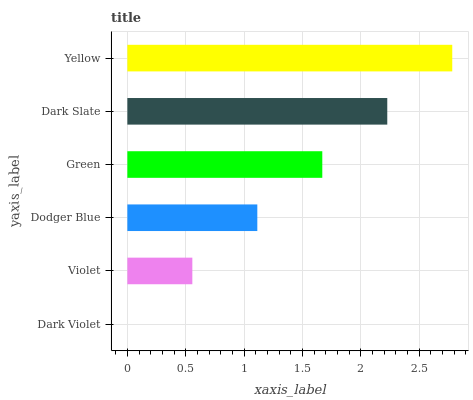Is Dark Violet the minimum?
Answer yes or no. Yes. Is Yellow the maximum?
Answer yes or no. Yes. Is Violet the minimum?
Answer yes or no. No. Is Violet the maximum?
Answer yes or no. No. Is Violet greater than Dark Violet?
Answer yes or no. Yes. Is Dark Violet less than Violet?
Answer yes or no. Yes. Is Dark Violet greater than Violet?
Answer yes or no. No. Is Violet less than Dark Violet?
Answer yes or no. No. Is Green the high median?
Answer yes or no. Yes. Is Dodger Blue the low median?
Answer yes or no. Yes. Is Dark Violet the high median?
Answer yes or no. No. Is Dark Slate the low median?
Answer yes or no. No. 